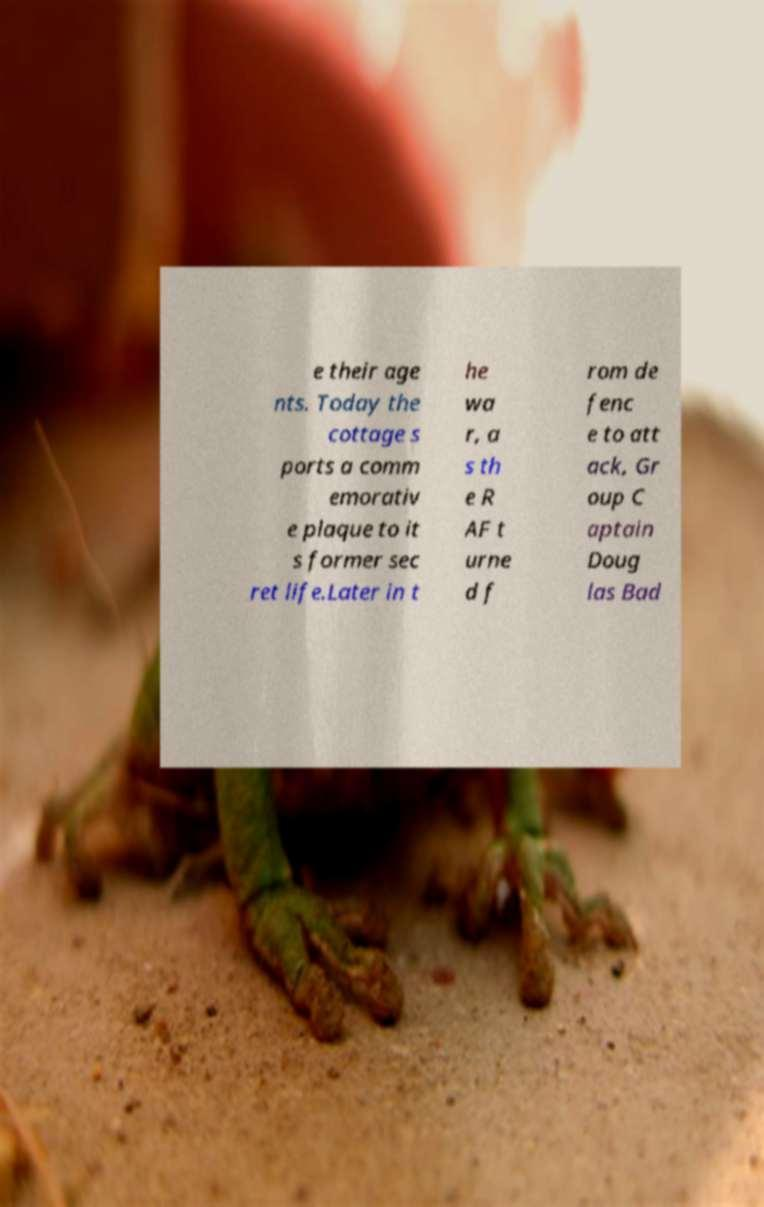For documentation purposes, I need the text within this image transcribed. Could you provide that? e their age nts. Today the cottage s ports a comm emorativ e plaque to it s former sec ret life.Later in t he wa r, a s th e R AF t urne d f rom de fenc e to att ack, Gr oup C aptain Doug las Bad 